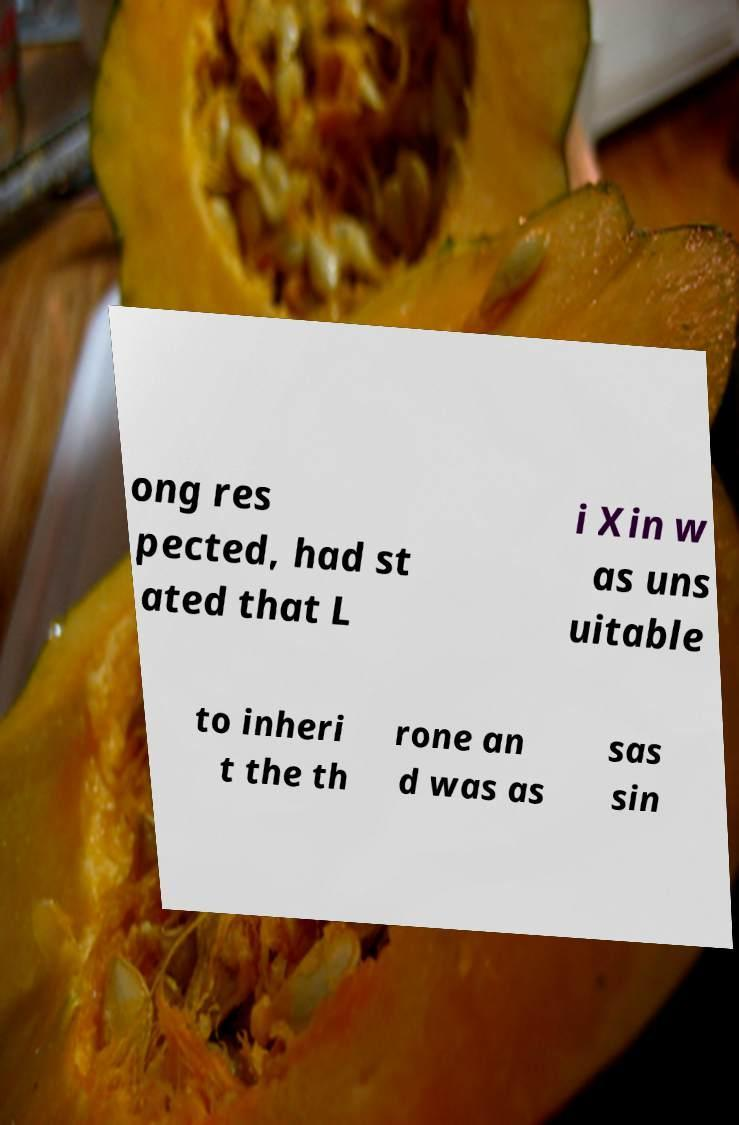What messages or text are displayed in this image? I need them in a readable, typed format. ong res pected, had st ated that L i Xin w as uns uitable to inheri t the th rone an d was as sas sin 